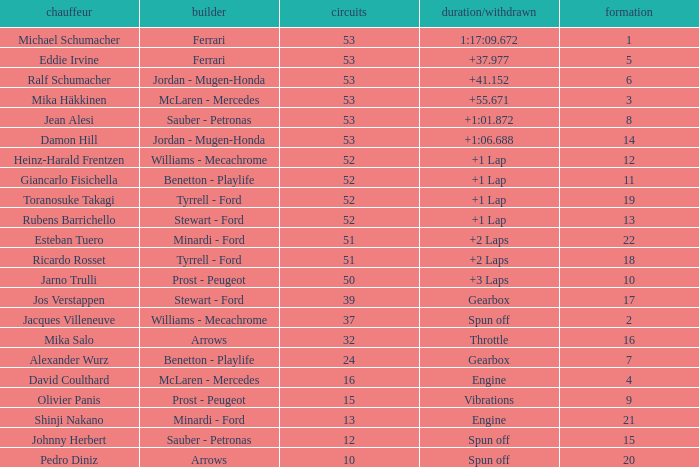What is the grid total for ralf schumacher racing over 53 laps? None. 